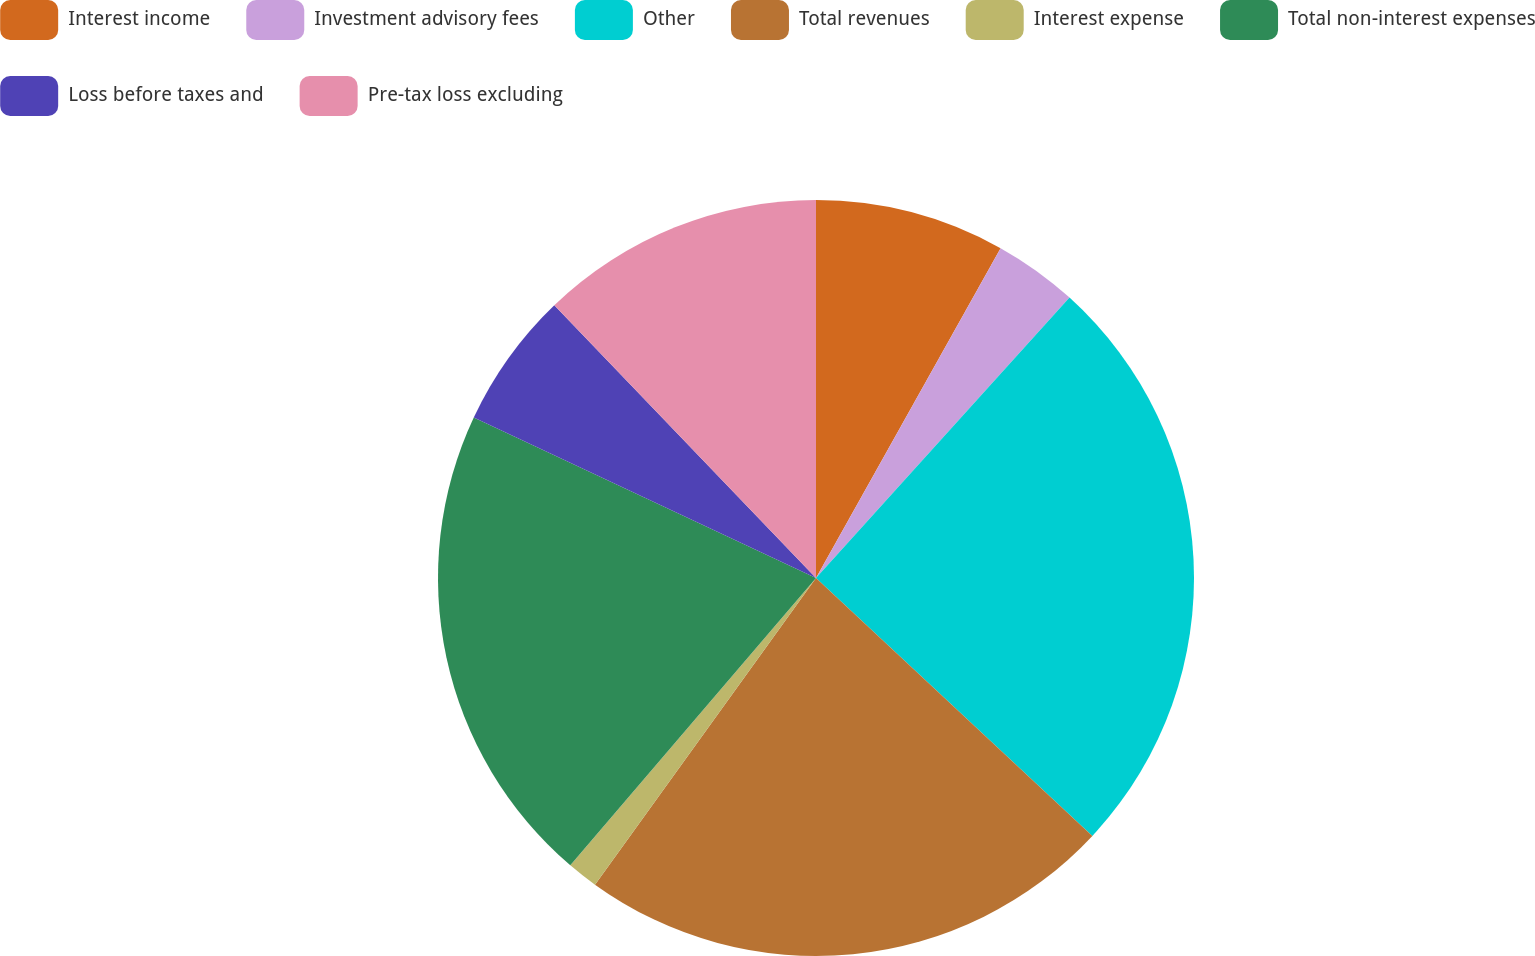Convert chart to OTSL. <chart><loc_0><loc_0><loc_500><loc_500><pie_chart><fcel>Interest income<fcel>Investment advisory fees<fcel>Other<fcel>Total revenues<fcel>Interest expense<fcel>Total non-interest expenses<fcel>Loss before taxes and<fcel>Pre-tax loss excluding<nl><fcel>8.12%<fcel>3.58%<fcel>25.25%<fcel>22.99%<fcel>1.32%<fcel>20.72%<fcel>5.85%<fcel>12.17%<nl></chart> 